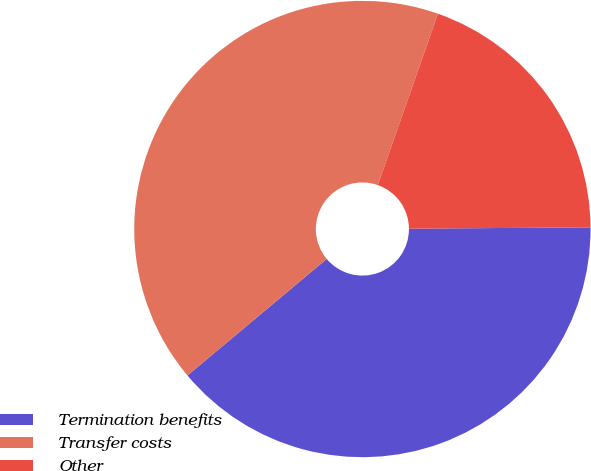Convert chart. <chart><loc_0><loc_0><loc_500><loc_500><pie_chart><fcel>Termination benefits<fcel>Transfer costs<fcel>Other<nl><fcel>39.02%<fcel>41.46%<fcel>19.51%<nl></chart> 